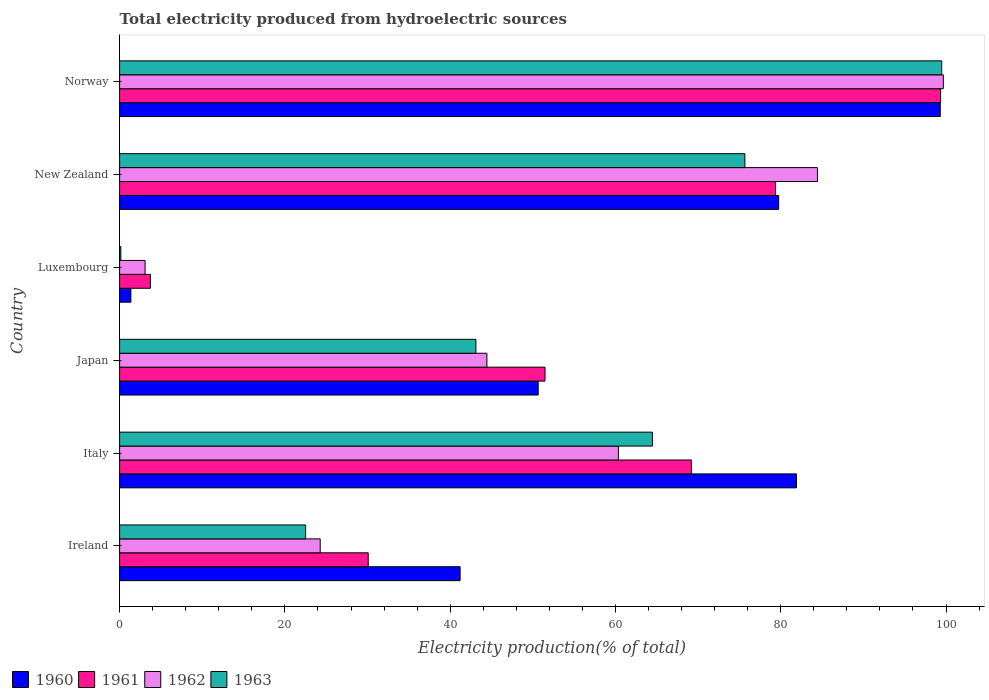Are the number of bars per tick equal to the number of legend labels?
Your answer should be compact. Yes. Are the number of bars on each tick of the Y-axis equal?
Give a very brief answer. Yes. How many bars are there on the 2nd tick from the top?
Your answer should be very brief. 4. How many bars are there on the 6th tick from the bottom?
Keep it short and to the point. 4. What is the label of the 2nd group of bars from the top?
Provide a short and direct response. New Zealand. In how many cases, is the number of bars for a given country not equal to the number of legend labels?
Make the answer very short. 0. What is the total electricity produced in 1961 in Ireland?
Offer a terse response. 30.09. Across all countries, what is the maximum total electricity produced in 1962?
Your answer should be compact. 99.67. Across all countries, what is the minimum total electricity produced in 1962?
Offer a terse response. 3.08. In which country was the total electricity produced in 1960 maximum?
Offer a very short reply. Norway. In which country was the total electricity produced in 1963 minimum?
Provide a short and direct response. Luxembourg. What is the total total electricity produced in 1961 in the graph?
Your response must be concise. 333.2. What is the difference between the total electricity produced in 1962 in Ireland and that in Japan?
Make the answer very short. -20.17. What is the difference between the total electricity produced in 1961 in Italy and the total electricity produced in 1962 in Luxembourg?
Your answer should be very brief. 66.11. What is the average total electricity produced in 1962 per country?
Make the answer very short. 52.71. What is the difference between the total electricity produced in 1960 and total electricity produced in 1961 in Ireland?
Offer a very short reply. 11.12. What is the ratio of the total electricity produced in 1962 in Italy to that in Norway?
Provide a succinct answer. 0.61. Is the total electricity produced in 1962 in Japan less than that in New Zealand?
Provide a succinct answer. Yes. Is the difference between the total electricity produced in 1960 in Ireland and Norway greater than the difference between the total electricity produced in 1961 in Ireland and Norway?
Ensure brevity in your answer.  Yes. What is the difference between the highest and the second highest total electricity produced in 1962?
Provide a short and direct response. 15.23. What is the difference between the highest and the lowest total electricity produced in 1963?
Provide a succinct answer. 99.33. In how many countries, is the total electricity produced in 1963 greater than the average total electricity produced in 1963 taken over all countries?
Your answer should be very brief. 3. Is the sum of the total electricity produced in 1963 in Ireland and Japan greater than the maximum total electricity produced in 1962 across all countries?
Give a very brief answer. No. What does the 4th bar from the bottom in Italy represents?
Provide a short and direct response. 1963. Is it the case that in every country, the sum of the total electricity produced in 1962 and total electricity produced in 1960 is greater than the total electricity produced in 1963?
Offer a very short reply. Yes. Are all the bars in the graph horizontal?
Keep it short and to the point. Yes. What is the difference between two consecutive major ticks on the X-axis?
Your answer should be compact. 20. Does the graph contain any zero values?
Give a very brief answer. No. Does the graph contain grids?
Your response must be concise. No. How are the legend labels stacked?
Offer a terse response. Horizontal. What is the title of the graph?
Your response must be concise. Total electricity produced from hydroelectric sources. Does "1991" appear as one of the legend labels in the graph?
Keep it short and to the point. No. What is the label or title of the X-axis?
Provide a short and direct response. Electricity production(% of total). What is the Electricity production(% of total) in 1960 in Ireland?
Provide a succinct answer. 41.2. What is the Electricity production(% of total) of 1961 in Ireland?
Offer a terse response. 30.09. What is the Electricity production(% of total) of 1962 in Ireland?
Give a very brief answer. 24.27. What is the Electricity production(% of total) of 1963 in Ireland?
Offer a very short reply. 22.51. What is the Electricity production(% of total) of 1960 in Italy?
Ensure brevity in your answer.  81.9. What is the Electricity production(% of total) in 1961 in Italy?
Offer a terse response. 69.19. What is the Electricity production(% of total) in 1962 in Italy?
Your answer should be very brief. 60.35. What is the Electricity production(% of total) of 1963 in Italy?
Provide a succinct answer. 64.47. What is the Electricity production(% of total) in 1960 in Japan?
Keep it short and to the point. 50.65. What is the Electricity production(% of total) of 1961 in Japan?
Keep it short and to the point. 51.48. What is the Electricity production(% of total) of 1962 in Japan?
Offer a terse response. 44.44. What is the Electricity production(% of total) in 1963 in Japan?
Provide a short and direct response. 43.11. What is the Electricity production(% of total) of 1960 in Luxembourg?
Provide a short and direct response. 1.37. What is the Electricity production(% of total) of 1961 in Luxembourg?
Ensure brevity in your answer.  3.73. What is the Electricity production(% of total) of 1962 in Luxembourg?
Offer a very short reply. 3.08. What is the Electricity production(% of total) in 1963 in Luxembourg?
Make the answer very short. 0.15. What is the Electricity production(% of total) in 1960 in New Zealand?
Your answer should be compact. 79.75. What is the Electricity production(% of total) in 1961 in New Zealand?
Your answer should be compact. 79.37. What is the Electricity production(% of total) of 1962 in New Zealand?
Offer a very short reply. 84.44. What is the Electricity production(% of total) of 1963 in New Zealand?
Keep it short and to the point. 75.66. What is the Electricity production(% of total) of 1960 in Norway?
Offer a very short reply. 99.3. What is the Electricity production(% of total) of 1961 in Norway?
Your answer should be very brief. 99.34. What is the Electricity production(% of total) in 1962 in Norway?
Your answer should be very brief. 99.67. What is the Electricity production(% of total) in 1963 in Norway?
Make the answer very short. 99.47. Across all countries, what is the maximum Electricity production(% of total) in 1960?
Your answer should be very brief. 99.3. Across all countries, what is the maximum Electricity production(% of total) in 1961?
Your answer should be compact. 99.34. Across all countries, what is the maximum Electricity production(% of total) in 1962?
Ensure brevity in your answer.  99.67. Across all countries, what is the maximum Electricity production(% of total) in 1963?
Ensure brevity in your answer.  99.47. Across all countries, what is the minimum Electricity production(% of total) of 1960?
Offer a terse response. 1.37. Across all countries, what is the minimum Electricity production(% of total) in 1961?
Your answer should be compact. 3.73. Across all countries, what is the minimum Electricity production(% of total) in 1962?
Ensure brevity in your answer.  3.08. Across all countries, what is the minimum Electricity production(% of total) in 1963?
Keep it short and to the point. 0.15. What is the total Electricity production(% of total) in 1960 in the graph?
Provide a short and direct response. 354.17. What is the total Electricity production(% of total) of 1961 in the graph?
Keep it short and to the point. 333.2. What is the total Electricity production(% of total) in 1962 in the graph?
Your response must be concise. 316.26. What is the total Electricity production(% of total) of 1963 in the graph?
Keep it short and to the point. 305.37. What is the difference between the Electricity production(% of total) in 1960 in Ireland and that in Italy?
Offer a terse response. -40.7. What is the difference between the Electricity production(% of total) of 1961 in Ireland and that in Italy?
Offer a terse response. -39.1. What is the difference between the Electricity production(% of total) in 1962 in Ireland and that in Italy?
Make the answer very short. -36.08. What is the difference between the Electricity production(% of total) of 1963 in Ireland and that in Italy?
Give a very brief answer. -41.96. What is the difference between the Electricity production(% of total) in 1960 in Ireland and that in Japan?
Give a very brief answer. -9.45. What is the difference between the Electricity production(% of total) in 1961 in Ireland and that in Japan?
Your answer should be compact. -21.39. What is the difference between the Electricity production(% of total) in 1962 in Ireland and that in Japan?
Make the answer very short. -20.17. What is the difference between the Electricity production(% of total) of 1963 in Ireland and that in Japan?
Offer a very short reply. -20.61. What is the difference between the Electricity production(% of total) of 1960 in Ireland and that in Luxembourg?
Offer a terse response. 39.84. What is the difference between the Electricity production(% of total) in 1961 in Ireland and that in Luxembourg?
Your answer should be compact. 26.36. What is the difference between the Electricity production(% of total) of 1962 in Ireland and that in Luxembourg?
Ensure brevity in your answer.  21.19. What is the difference between the Electricity production(% of total) of 1963 in Ireland and that in Luxembourg?
Provide a short and direct response. 22.36. What is the difference between the Electricity production(% of total) of 1960 in Ireland and that in New Zealand?
Provide a short and direct response. -38.55. What is the difference between the Electricity production(% of total) in 1961 in Ireland and that in New Zealand?
Keep it short and to the point. -49.29. What is the difference between the Electricity production(% of total) of 1962 in Ireland and that in New Zealand?
Give a very brief answer. -60.17. What is the difference between the Electricity production(% of total) in 1963 in Ireland and that in New Zealand?
Keep it short and to the point. -53.15. What is the difference between the Electricity production(% of total) of 1960 in Ireland and that in Norway?
Provide a succinct answer. -58.1. What is the difference between the Electricity production(% of total) of 1961 in Ireland and that in Norway?
Give a very brief answer. -69.26. What is the difference between the Electricity production(% of total) in 1962 in Ireland and that in Norway?
Your answer should be compact. -75.4. What is the difference between the Electricity production(% of total) of 1963 in Ireland and that in Norway?
Offer a very short reply. -76.97. What is the difference between the Electricity production(% of total) in 1960 in Italy and that in Japan?
Provide a succinct answer. 31.25. What is the difference between the Electricity production(% of total) of 1961 in Italy and that in Japan?
Give a very brief answer. 17.71. What is the difference between the Electricity production(% of total) in 1962 in Italy and that in Japan?
Your answer should be very brief. 15.91. What is the difference between the Electricity production(% of total) in 1963 in Italy and that in Japan?
Provide a succinct answer. 21.35. What is the difference between the Electricity production(% of total) in 1960 in Italy and that in Luxembourg?
Give a very brief answer. 80.53. What is the difference between the Electricity production(% of total) in 1961 in Italy and that in Luxembourg?
Ensure brevity in your answer.  65.46. What is the difference between the Electricity production(% of total) in 1962 in Italy and that in Luxembourg?
Your answer should be very brief. 57.27. What is the difference between the Electricity production(% of total) of 1963 in Italy and that in Luxembourg?
Provide a short and direct response. 64.32. What is the difference between the Electricity production(% of total) of 1960 in Italy and that in New Zealand?
Provide a succinct answer. 2.15. What is the difference between the Electricity production(% of total) of 1961 in Italy and that in New Zealand?
Your response must be concise. -10.18. What is the difference between the Electricity production(% of total) of 1962 in Italy and that in New Zealand?
Offer a terse response. -24.08. What is the difference between the Electricity production(% of total) of 1963 in Italy and that in New Zealand?
Offer a terse response. -11.19. What is the difference between the Electricity production(% of total) of 1960 in Italy and that in Norway?
Offer a terse response. -17.4. What is the difference between the Electricity production(% of total) in 1961 in Italy and that in Norway?
Offer a terse response. -30.15. What is the difference between the Electricity production(% of total) of 1962 in Italy and that in Norway?
Give a very brief answer. -39.32. What is the difference between the Electricity production(% of total) of 1963 in Italy and that in Norway?
Keep it short and to the point. -35.01. What is the difference between the Electricity production(% of total) in 1960 in Japan and that in Luxembourg?
Your answer should be very brief. 49.28. What is the difference between the Electricity production(% of total) of 1961 in Japan and that in Luxembourg?
Your answer should be very brief. 47.75. What is the difference between the Electricity production(% of total) of 1962 in Japan and that in Luxembourg?
Offer a very short reply. 41.36. What is the difference between the Electricity production(% of total) of 1963 in Japan and that in Luxembourg?
Provide a short and direct response. 42.97. What is the difference between the Electricity production(% of total) in 1960 in Japan and that in New Zealand?
Make the answer very short. -29.1. What is the difference between the Electricity production(% of total) of 1961 in Japan and that in New Zealand?
Provide a succinct answer. -27.9. What is the difference between the Electricity production(% of total) of 1962 in Japan and that in New Zealand?
Your answer should be very brief. -39.99. What is the difference between the Electricity production(% of total) of 1963 in Japan and that in New Zealand?
Give a very brief answer. -32.54. What is the difference between the Electricity production(% of total) in 1960 in Japan and that in Norway?
Your answer should be compact. -48.65. What is the difference between the Electricity production(% of total) in 1961 in Japan and that in Norway?
Your response must be concise. -47.87. What is the difference between the Electricity production(% of total) of 1962 in Japan and that in Norway?
Give a very brief answer. -55.23. What is the difference between the Electricity production(% of total) in 1963 in Japan and that in Norway?
Provide a succinct answer. -56.36. What is the difference between the Electricity production(% of total) of 1960 in Luxembourg and that in New Zealand?
Offer a very short reply. -78.38. What is the difference between the Electricity production(% of total) in 1961 in Luxembourg and that in New Zealand?
Provide a succinct answer. -75.64. What is the difference between the Electricity production(% of total) in 1962 in Luxembourg and that in New Zealand?
Your response must be concise. -81.36. What is the difference between the Electricity production(% of total) of 1963 in Luxembourg and that in New Zealand?
Offer a very short reply. -75.51. What is the difference between the Electricity production(% of total) of 1960 in Luxembourg and that in Norway?
Keep it short and to the point. -97.93. What is the difference between the Electricity production(% of total) in 1961 in Luxembourg and that in Norway?
Ensure brevity in your answer.  -95.61. What is the difference between the Electricity production(% of total) in 1962 in Luxembourg and that in Norway?
Give a very brief answer. -96.59. What is the difference between the Electricity production(% of total) of 1963 in Luxembourg and that in Norway?
Your answer should be very brief. -99.33. What is the difference between the Electricity production(% of total) of 1960 in New Zealand and that in Norway?
Keep it short and to the point. -19.55. What is the difference between the Electricity production(% of total) in 1961 in New Zealand and that in Norway?
Keep it short and to the point. -19.97. What is the difference between the Electricity production(% of total) in 1962 in New Zealand and that in Norway?
Your answer should be compact. -15.23. What is the difference between the Electricity production(% of total) in 1963 in New Zealand and that in Norway?
Your answer should be compact. -23.82. What is the difference between the Electricity production(% of total) of 1960 in Ireland and the Electricity production(% of total) of 1961 in Italy?
Make the answer very short. -27.99. What is the difference between the Electricity production(% of total) in 1960 in Ireland and the Electricity production(% of total) in 1962 in Italy?
Your response must be concise. -19.15. What is the difference between the Electricity production(% of total) of 1960 in Ireland and the Electricity production(% of total) of 1963 in Italy?
Keep it short and to the point. -23.27. What is the difference between the Electricity production(% of total) of 1961 in Ireland and the Electricity production(% of total) of 1962 in Italy?
Ensure brevity in your answer.  -30.27. What is the difference between the Electricity production(% of total) in 1961 in Ireland and the Electricity production(% of total) in 1963 in Italy?
Give a very brief answer. -34.38. What is the difference between the Electricity production(% of total) of 1962 in Ireland and the Electricity production(% of total) of 1963 in Italy?
Provide a short and direct response. -40.2. What is the difference between the Electricity production(% of total) in 1960 in Ireland and the Electricity production(% of total) in 1961 in Japan?
Keep it short and to the point. -10.27. What is the difference between the Electricity production(% of total) in 1960 in Ireland and the Electricity production(% of total) in 1962 in Japan?
Offer a very short reply. -3.24. What is the difference between the Electricity production(% of total) of 1960 in Ireland and the Electricity production(% of total) of 1963 in Japan?
Provide a short and direct response. -1.91. What is the difference between the Electricity production(% of total) in 1961 in Ireland and the Electricity production(% of total) in 1962 in Japan?
Your answer should be compact. -14.36. What is the difference between the Electricity production(% of total) of 1961 in Ireland and the Electricity production(% of total) of 1963 in Japan?
Keep it short and to the point. -13.03. What is the difference between the Electricity production(% of total) in 1962 in Ireland and the Electricity production(% of total) in 1963 in Japan?
Provide a short and direct response. -18.84. What is the difference between the Electricity production(% of total) in 1960 in Ireland and the Electricity production(% of total) in 1961 in Luxembourg?
Keep it short and to the point. 37.47. What is the difference between the Electricity production(% of total) of 1960 in Ireland and the Electricity production(% of total) of 1962 in Luxembourg?
Your answer should be compact. 38.12. What is the difference between the Electricity production(% of total) in 1960 in Ireland and the Electricity production(% of total) in 1963 in Luxembourg?
Your answer should be compact. 41.05. What is the difference between the Electricity production(% of total) of 1961 in Ireland and the Electricity production(% of total) of 1962 in Luxembourg?
Offer a very short reply. 27. What is the difference between the Electricity production(% of total) in 1961 in Ireland and the Electricity production(% of total) in 1963 in Luxembourg?
Make the answer very short. 29.94. What is the difference between the Electricity production(% of total) in 1962 in Ireland and the Electricity production(% of total) in 1963 in Luxembourg?
Offer a very short reply. 24.12. What is the difference between the Electricity production(% of total) in 1960 in Ireland and the Electricity production(% of total) in 1961 in New Zealand?
Provide a short and direct response. -38.17. What is the difference between the Electricity production(% of total) of 1960 in Ireland and the Electricity production(% of total) of 1962 in New Zealand?
Keep it short and to the point. -43.24. What is the difference between the Electricity production(% of total) in 1960 in Ireland and the Electricity production(% of total) in 1963 in New Zealand?
Give a very brief answer. -34.46. What is the difference between the Electricity production(% of total) of 1961 in Ireland and the Electricity production(% of total) of 1962 in New Zealand?
Provide a short and direct response. -54.35. What is the difference between the Electricity production(% of total) in 1961 in Ireland and the Electricity production(% of total) in 1963 in New Zealand?
Offer a very short reply. -45.57. What is the difference between the Electricity production(% of total) in 1962 in Ireland and the Electricity production(% of total) in 1963 in New Zealand?
Ensure brevity in your answer.  -51.39. What is the difference between the Electricity production(% of total) in 1960 in Ireland and the Electricity production(% of total) in 1961 in Norway?
Your answer should be very brief. -58.14. What is the difference between the Electricity production(% of total) of 1960 in Ireland and the Electricity production(% of total) of 1962 in Norway?
Your answer should be very brief. -58.47. What is the difference between the Electricity production(% of total) of 1960 in Ireland and the Electricity production(% of total) of 1963 in Norway?
Provide a short and direct response. -58.27. What is the difference between the Electricity production(% of total) of 1961 in Ireland and the Electricity production(% of total) of 1962 in Norway?
Offer a terse response. -69.58. What is the difference between the Electricity production(% of total) in 1961 in Ireland and the Electricity production(% of total) in 1963 in Norway?
Keep it short and to the point. -69.39. What is the difference between the Electricity production(% of total) in 1962 in Ireland and the Electricity production(% of total) in 1963 in Norway?
Provide a short and direct response. -75.2. What is the difference between the Electricity production(% of total) of 1960 in Italy and the Electricity production(% of total) of 1961 in Japan?
Provide a short and direct response. 30.42. What is the difference between the Electricity production(% of total) in 1960 in Italy and the Electricity production(% of total) in 1962 in Japan?
Your answer should be compact. 37.46. What is the difference between the Electricity production(% of total) in 1960 in Italy and the Electricity production(% of total) in 1963 in Japan?
Make the answer very short. 38.79. What is the difference between the Electricity production(% of total) in 1961 in Italy and the Electricity production(% of total) in 1962 in Japan?
Your response must be concise. 24.75. What is the difference between the Electricity production(% of total) in 1961 in Italy and the Electricity production(% of total) in 1963 in Japan?
Give a very brief answer. 26.08. What is the difference between the Electricity production(% of total) in 1962 in Italy and the Electricity production(% of total) in 1963 in Japan?
Offer a very short reply. 17.24. What is the difference between the Electricity production(% of total) in 1960 in Italy and the Electricity production(% of total) in 1961 in Luxembourg?
Provide a short and direct response. 78.17. What is the difference between the Electricity production(% of total) in 1960 in Italy and the Electricity production(% of total) in 1962 in Luxembourg?
Make the answer very short. 78.82. What is the difference between the Electricity production(% of total) of 1960 in Italy and the Electricity production(% of total) of 1963 in Luxembourg?
Your response must be concise. 81.75. What is the difference between the Electricity production(% of total) in 1961 in Italy and the Electricity production(% of total) in 1962 in Luxembourg?
Ensure brevity in your answer.  66.11. What is the difference between the Electricity production(% of total) in 1961 in Italy and the Electricity production(% of total) in 1963 in Luxembourg?
Your response must be concise. 69.04. What is the difference between the Electricity production(% of total) in 1962 in Italy and the Electricity production(% of total) in 1963 in Luxembourg?
Give a very brief answer. 60.21. What is the difference between the Electricity production(% of total) of 1960 in Italy and the Electricity production(% of total) of 1961 in New Zealand?
Keep it short and to the point. 2.53. What is the difference between the Electricity production(% of total) in 1960 in Italy and the Electricity production(% of total) in 1962 in New Zealand?
Offer a terse response. -2.54. What is the difference between the Electricity production(% of total) of 1960 in Italy and the Electricity production(% of total) of 1963 in New Zealand?
Provide a succinct answer. 6.24. What is the difference between the Electricity production(% of total) of 1961 in Italy and the Electricity production(% of total) of 1962 in New Zealand?
Provide a succinct answer. -15.25. What is the difference between the Electricity production(% of total) in 1961 in Italy and the Electricity production(% of total) in 1963 in New Zealand?
Keep it short and to the point. -6.47. What is the difference between the Electricity production(% of total) in 1962 in Italy and the Electricity production(% of total) in 1963 in New Zealand?
Your answer should be very brief. -15.3. What is the difference between the Electricity production(% of total) of 1960 in Italy and the Electricity production(% of total) of 1961 in Norway?
Ensure brevity in your answer.  -17.44. What is the difference between the Electricity production(% of total) of 1960 in Italy and the Electricity production(% of total) of 1962 in Norway?
Give a very brief answer. -17.77. What is the difference between the Electricity production(% of total) of 1960 in Italy and the Electricity production(% of total) of 1963 in Norway?
Your answer should be compact. -17.57. What is the difference between the Electricity production(% of total) of 1961 in Italy and the Electricity production(% of total) of 1962 in Norway?
Offer a terse response. -30.48. What is the difference between the Electricity production(% of total) of 1961 in Italy and the Electricity production(% of total) of 1963 in Norway?
Provide a succinct answer. -30.28. What is the difference between the Electricity production(% of total) of 1962 in Italy and the Electricity production(% of total) of 1963 in Norway?
Keep it short and to the point. -39.12. What is the difference between the Electricity production(% of total) of 1960 in Japan and the Electricity production(% of total) of 1961 in Luxembourg?
Provide a short and direct response. 46.92. What is the difference between the Electricity production(% of total) of 1960 in Japan and the Electricity production(% of total) of 1962 in Luxembourg?
Your answer should be compact. 47.57. What is the difference between the Electricity production(% of total) of 1960 in Japan and the Electricity production(% of total) of 1963 in Luxembourg?
Your response must be concise. 50.5. What is the difference between the Electricity production(% of total) of 1961 in Japan and the Electricity production(% of total) of 1962 in Luxembourg?
Ensure brevity in your answer.  48.39. What is the difference between the Electricity production(% of total) in 1961 in Japan and the Electricity production(% of total) in 1963 in Luxembourg?
Your answer should be very brief. 51.33. What is the difference between the Electricity production(% of total) in 1962 in Japan and the Electricity production(% of total) in 1963 in Luxembourg?
Give a very brief answer. 44.3. What is the difference between the Electricity production(% of total) of 1960 in Japan and the Electricity production(% of total) of 1961 in New Zealand?
Offer a very short reply. -28.72. What is the difference between the Electricity production(% of total) in 1960 in Japan and the Electricity production(% of total) in 1962 in New Zealand?
Keep it short and to the point. -33.79. What is the difference between the Electricity production(% of total) in 1960 in Japan and the Electricity production(% of total) in 1963 in New Zealand?
Provide a succinct answer. -25.01. What is the difference between the Electricity production(% of total) of 1961 in Japan and the Electricity production(% of total) of 1962 in New Zealand?
Offer a very short reply. -32.96. What is the difference between the Electricity production(% of total) of 1961 in Japan and the Electricity production(% of total) of 1963 in New Zealand?
Your response must be concise. -24.18. What is the difference between the Electricity production(% of total) in 1962 in Japan and the Electricity production(% of total) in 1963 in New Zealand?
Offer a very short reply. -31.21. What is the difference between the Electricity production(% of total) of 1960 in Japan and the Electricity production(% of total) of 1961 in Norway?
Keep it short and to the point. -48.69. What is the difference between the Electricity production(% of total) in 1960 in Japan and the Electricity production(% of total) in 1962 in Norway?
Your response must be concise. -49.02. What is the difference between the Electricity production(% of total) in 1960 in Japan and the Electricity production(% of total) in 1963 in Norway?
Your answer should be very brief. -48.83. What is the difference between the Electricity production(% of total) of 1961 in Japan and the Electricity production(% of total) of 1962 in Norway?
Offer a terse response. -48.19. What is the difference between the Electricity production(% of total) in 1961 in Japan and the Electricity production(% of total) in 1963 in Norway?
Your answer should be compact. -48. What is the difference between the Electricity production(% of total) of 1962 in Japan and the Electricity production(% of total) of 1963 in Norway?
Make the answer very short. -55.03. What is the difference between the Electricity production(% of total) of 1960 in Luxembourg and the Electricity production(% of total) of 1961 in New Zealand?
Ensure brevity in your answer.  -78.01. What is the difference between the Electricity production(% of total) in 1960 in Luxembourg and the Electricity production(% of total) in 1962 in New Zealand?
Your answer should be compact. -83.07. What is the difference between the Electricity production(% of total) of 1960 in Luxembourg and the Electricity production(% of total) of 1963 in New Zealand?
Keep it short and to the point. -74.29. What is the difference between the Electricity production(% of total) of 1961 in Luxembourg and the Electricity production(% of total) of 1962 in New Zealand?
Your answer should be compact. -80.71. What is the difference between the Electricity production(% of total) of 1961 in Luxembourg and the Electricity production(% of total) of 1963 in New Zealand?
Offer a very short reply. -71.93. What is the difference between the Electricity production(% of total) in 1962 in Luxembourg and the Electricity production(% of total) in 1963 in New Zealand?
Give a very brief answer. -72.58. What is the difference between the Electricity production(% of total) in 1960 in Luxembourg and the Electricity production(% of total) in 1961 in Norway?
Your answer should be compact. -97.98. What is the difference between the Electricity production(% of total) of 1960 in Luxembourg and the Electricity production(% of total) of 1962 in Norway?
Your response must be concise. -98.3. What is the difference between the Electricity production(% of total) in 1960 in Luxembourg and the Electricity production(% of total) in 1963 in Norway?
Keep it short and to the point. -98.11. What is the difference between the Electricity production(% of total) of 1961 in Luxembourg and the Electricity production(% of total) of 1962 in Norway?
Provide a succinct answer. -95.94. What is the difference between the Electricity production(% of total) of 1961 in Luxembourg and the Electricity production(% of total) of 1963 in Norway?
Offer a very short reply. -95.74. What is the difference between the Electricity production(% of total) in 1962 in Luxembourg and the Electricity production(% of total) in 1963 in Norway?
Your response must be concise. -96.39. What is the difference between the Electricity production(% of total) of 1960 in New Zealand and the Electricity production(% of total) of 1961 in Norway?
Your answer should be very brief. -19.59. What is the difference between the Electricity production(% of total) in 1960 in New Zealand and the Electricity production(% of total) in 1962 in Norway?
Your answer should be very brief. -19.92. What is the difference between the Electricity production(% of total) of 1960 in New Zealand and the Electricity production(% of total) of 1963 in Norway?
Ensure brevity in your answer.  -19.72. What is the difference between the Electricity production(% of total) in 1961 in New Zealand and the Electricity production(% of total) in 1962 in Norway?
Offer a terse response. -20.3. What is the difference between the Electricity production(% of total) in 1961 in New Zealand and the Electricity production(% of total) in 1963 in Norway?
Ensure brevity in your answer.  -20.1. What is the difference between the Electricity production(% of total) in 1962 in New Zealand and the Electricity production(% of total) in 1963 in Norway?
Your answer should be compact. -15.04. What is the average Electricity production(% of total) in 1960 per country?
Make the answer very short. 59.03. What is the average Electricity production(% of total) of 1961 per country?
Ensure brevity in your answer.  55.53. What is the average Electricity production(% of total) of 1962 per country?
Give a very brief answer. 52.71. What is the average Electricity production(% of total) in 1963 per country?
Give a very brief answer. 50.9. What is the difference between the Electricity production(% of total) in 1960 and Electricity production(% of total) in 1961 in Ireland?
Your response must be concise. 11.12. What is the difference between the Electricity production(% of total) in 1960 and Electricity production(% of total) in 1962 in Ireland?
Offer a terse response. 16.93. What is the difference between the Electricity production(% of total) of 1960 and Electricity production(% of total) of 1963 in Ireland?
Provide a short and direct response. 18.69. What is the difference between the Electricity production(% of total) in 1961 and Electricity production(% of total) in 1962 in Ireland?
Provide a short and direct response. 5.81. What is the difference between the Electricity production(% of total) of 1961 and Electricity production(% of total) of 1963 in Ireland?
Offer a very short reply. 7.58. What is the difference between the Electricity production(% of total) of 1962 and Electricity production(% of total) of 1963 in Ireland?
Offer a very short reply. 1.76. What is the difference between the Electricity production(% of total) of 1960 and Electricity production(% of total) of 1961 in Italy?
Provide a succinct answer. 12.71. What is the difference between the Electricity production(% of total) in 1960 and Electricity production(% of total) in 1962 in Italy?
Offer a very short reply. 21.55. What is the difference between the Electricity production(% of total) of 1960 and Electricity production(% of total) of 1963 in Italy?
Your response must be concise. 17.43. What is the difference between the Electricity production(% of total) in 1961 and Electricity production(% of total) in 1962 in Italy?
Ensure brevity in your answer.  8.84. What is the difference between the Electricity production(% of total) of 1961 and Electricity production(% of total) of 1963 in Italy?
Make the answer very short. 4.72. What is the difference between the Electricity production(% of total) of 1962 and Electricity production(% of total) of 1963 in Italy?
Give a very brief answer. -4.11. What is the difference between the Electricity production(% of total) in 1960 and Electricity production(% of total) in 1961 in Japan?
Your answer should be very brief. -0.83. What is the difference between the Electricity production(% of total) of 1960 and Electricity production(% of total) of 1962 in Japan?
Your response must be concise. 6.2. What is the difference between the Electricity production(% of total) of 1960 and Electricity production(% of total) of 1963 in Japan?
Offer a very short reply. 7.54. What is the difference between the Electricity production(% of total) of 1961 and Electricity production(% of total) of 1962 in Japan?
Give a very brief answer. 7.03. What is the difference between the Electricity production(% of total) in 1961 and Electricity production(% of total) in 1963 in Japan?
Make the answer very short. 8.36. What is the difference between the Electricity production(% of total) of 1962 and Electricity production(% of total) of 1963 in Japan?
Keep it short and to the point. 1.33. What is the difference between the Electricity production(% of total) in 1960 and Electricity production(% of total) in 1961 in Luxembourg?
Provide a short and direct response. -2.36. What is the difference between the Electricity production(% of total) in 1960 and Electricity production(% of total) in 1962 in Luxembourg?
Offer a terse response. -1.72. What is the difference between the Electricity production(% of total) of 1960 and Electricity production(% of total) of 1963 in Luxembourg?
Your answer should be very brief. 1.22. What is the difference between the Electricity production(% of total) in 1961 and Electricity production(% of total) in 1962 in Luxembourg?
Your answer should be very brief. 0.65. What is the difference between the Electricity production(% of total) of 1961 and Electricity production(% of total) of 1963 in Luxembourg?
Ensure brevity in your answer.  3.58. What is the difference between the Electricity production(% of total) of 1962 and Electricity production(% of total) of 1963 in Luxembourg?
Provide a short and direct response. 2.93. What is the difference between the Electricity production(% of total) of 1960 and Electricity production(% of total) of 1961 in New Zealand?
Offer a very short reply. 0.38. What is the difference between the Electricity production(% of total) in 1960 and Electricity production(% of total) in 1962 in New Zealand?
Offer a very short reply. -4.69. What is the difference between the Electricity production(% of total) of 1960 and Electricity production(% of total) of 1963 in New Zealand?
Offer a very short reply. 4.09. What is the difference between the Electricity production(% of total) in 1961 and Electricity production(% of total) in 1962 in New Zealand?
Your answer should be very brief. -5.07. What is the difference between the Electricity production(% of total) in 1961 and Electricity production(% of total) in 1963 in New Zealand?
Keep it short and to the point. 3.71. What is the difference between the Electricity production(% of total) in 1962 and Electricity production(% of total) in 1963 in New Zealand?
Offer a terse response. 8.78. What is the difference between the Electricity production(% of total) in 1960 and Electricity production(% of total) in 1961 in Norway?
Ensure brevity in your answer.  -0.04. What is the difference between the Electricity production(% of total) in 1960 and Electricity production(% of total) in 1962 in Norway?
Your response must be concise. -0.37. What is the difference between the Electricity production(% of total) of 1960 and Electricity production(% of total) of 1963 in Norway?
Give a very brief answer. -0.17. What is the difference between the Electricity production(% of total) of 1961 and Electricity production(% of total) of 1962 in Norway?
Keep it short and to the point. -0.33. What is the difference between the Electricity production(% of total) of 1961 and Electricity production(% of total) of 1963 in Norway?
Keep it short and to the point. -0.13. What is the difference between the Electricity production(% of total) of 1962 and Electricity production(% of total) of 1963 in Norway?
Offer a very short reply. 0.19. What is the ratio of the Electricity production(% of total) in 1960 in Ireland to that in Italy?
Provide a short and direct response. 0.5. What is the ratio of the Electricity production(% of total) of 1961 in Ireland to that in Italy?
Your answer should be compact. 0.43. What is the ratio of the Electricity production(% of total) in 1962 in Ireland to that in Italy?
Provide a short and direct response. 0.4. What is the ratio of the Electricity production(% of total) in 1963 in Ireland to that in Italy?
Ensure brevity in your answer.  0.35. What is the ratio of the Electricity production(% of total) in 1960 in Ireland to that in Japan?
Offer a terse response. 0.81. What is the ratio of the Electricity production(% of total) in 1961 in Ireland to that in Japan?
Provide a succinct answer. 0.58. What is the ratio of the Electricity production(% of total) in 1962 in Ireland to that in Japan?
Offer a very short reply. 0.55. What is the ratio of the Electricity production(% of total) of 1963 in Ireland to that in Japan?
Offer a terse response. 0.52. What is the ratio of the Electricity production(% of total) of 1960 in Ireland to that in Luxembourg?
Give a very brief answer. 30.16. What is the ratio of the Electricity production(% of total) of 1961 in Ireland to that in Luxembourg?
Offer a very short reply. 8.07. What is the ratio of the Electricity production(% of total) of 1962 in Ireland to that in Luxembourg?
Offer a very short reply. 7.88. What is the ratio of the Electricity production(% of total) of 1963 in Ireland to that in Luxembourg?
Provide a short and direct response. 152.5. What is the ratio of the Electricity production(% of total) of 1960 in Ireland to that in New Zealand?
Ensure brevity in your answer.  0.52. What is the ratio of the Electricity production(% of total) of 1961 in Ireland to that in New Zealand?
Your answer should be very brief. 0.38. What is the ratio of the Electricity production(% of total) of 1962 in Ireland to that in New Zealand?
Give a very brief answer. 0.29. What is the ratio of the Electricity production(% of total) of 1963 in Ireland to that in New Zealand?
Offer a terse response. 0.3. What is the ratio of the Electricity production(% of total) in 1960 in Ireland to that in Norway?
Keep it short and to the point. 0.41. What is the ratio of the Electricity production(% of total) in 1961 in Ireland to that in Norway?
Your response must be concise. 0.3. What is the ratio of the Electricity production(% of total) in 1962 in Ireland to that in Norway?
Make the answer very short. 0.24. What is the ratio of the Electricity production(% of total) in 1963 in Ireland to that in Norway?
Your answer should be compact. 0.23. What is the ratio of the Electricity production(% of total) of 1960 in Italy to that in Japan?
Offer a terse response. 1.62. What is the ratio of the Electricity production(% of total) in 1961 in Italy to that in Japan?
Give a very brief answer. 1.34. What is the ratio of the Electricity production(% of total) in 1962 in Italy to that in Japan?
Your answer should be very brief. 1.36. What is the ratio of the Electricity production(% of total) of 1963 in Italy to that in Japan?
Make the answer very short. 1.5. What is the ratio of the Electricity production(% of total) of 1960 in Italy to that in Luxembourg?
Give a very brief answer. 59.95. What is the ratio of the Electricity production(% of total) in 1961 in Italy to that in Luxembourg?
Give a very brief answer. 18.55. What is the ratio of the Electricity production(% of total) of 1962 in Italy to that in Luxembourg?
Your answer should be very brief. 19.58. What is the ratio of the Electricity production(% of total) in 1963 in Italy to that in Luxembourg?
Your answer should be compact. 436.77. What is the ratio of the Electricity production(% of total) of 1961 in Italy to that in New Zealand?
Keep it short and to the point. 0.87. What is the ratio of the Electricity production(% of total) in 1962 in Italy to that in New Zealand?
Give a very brief answer. 0.71. What is the ratio of the Electricity production(% of total) in 1963 in Italy to that in New Zealand?
Ensure brevity in your answer.  0.85. What is the ratio of the Electricity production(% of total) in 1960 in Italy to that in Norway?
Your answer should be compact. 0.82. What is the ratio of the Electricity production(% of total) of 1961 in Italy to that in Norway?
Keep it short and to the point. 0.7. What is the ratio of the Electricity production(% of total) in 1962 in Italy to that in Norway?
Provide a succinct answer. 0.61. What is the ratio of the Electricity production(% of total) in 1963 in Italy to that in Norway?
Your response must be concise. 0.65. What is the ratio of the Electricity production(% of total) of 1960 in Japan to that in Luxembourg?
Make the answer very short. 37.08. What is the ratio of the Electricity production(% of total) in 1961 in Japan to that in Luxembourg?
Your response must be concise. 13.8. What is the ratio of the Electricity production(% of total) in 1962 in Japan to that in Luxembourg?
Your answer should be compact. 14.42. What is the ratio of the Electricity production(% of total) of 1963 in Japan to that in Luxembourg?
Your answer should be compact. 292.1. What is the ratio of the Electricity production(% of total) in 1960 in Japan to that in New Zealand?
Provide a short and direct response. 0.64. What is the ratio of the Electricity production(% of total) in 1961 in Japan to that in New Zealand?
Keep it short and to the point. 0.65. What is the ratio of the Electricity production(% of total) in 1962 in Japan to that in New Zealand?
Make the answer very short. 0.53. What is the ratio of the Electricity production(% of total) of 1963 in Japan to that in New Zealand?
Offer a terse response. 0.57. What is the ratio of the Electricity production(% of total) in 1960 in Japan to that in Norway?
Your answer should be very brief. 0.51. What is the ratio of the Electricity production(% of total) in 1961 in Japan to that in Norway?
Provide a short and direct response. 0.52. What is the ratio of the Electricity production(% of total) of 1962 in Japan to that in Norway?
Provide a short and direct response. 0.45. What is the ratio of the Electricity production(% of total) in 1963 in Japan to that in Norway?
Your answer should be very brief. 0.43. What is the ratio of the Electricity production(% of total) of 1960 in Luxembourg to that in New Zealand?
Provide a short and direct response. 0.02. What is the ratio of the Electricity production(% of total) of 1961 in Luxembourg to that in New Zealand?
Ensure brevity in your answer.  0.05. What is the ratio of the Electricity production(% of total) of 1962 in Luxembourg to that in New Zealand?
Keep it short and to the point. 0.04. What is the ratio of the Electricity production(% of total) of 1963 in Luxembourg to that in New Zealand?
Your answer should be compact. 0. What is the ratio of the Electricity production(% of total) of 1960 in Luxembourg to that in Norway?
Keep it short and to the point. 0.01. What is the ratio of the Electricity production(% of total) of 1961 in Luxembourg to that in Norway?
Provide a short and direct response. 0.04. What is the ratio of the Electricity production(% of total) of 1962 in Luxembourg to that in Norway?
Ensure brevity in your answer.  0.03. What is the ratio of the Electricity production(% of total) in 1963 in Luxembourg to that in Norway?
Give a very brief answer. 0. What is the ratio of the Electricity production(% of total) of 1960 in New Zealand to that in Norway?
Provide a short and direct response. 0.8. What is the ratio of the Electricity production(% of total) of 1961 in New Zealand to that in Norway?
Your response must be concise. 0.8. What is the ratio of the Electricity production(% of total) in 1962 in New Zealand to that in Norway?
Give a very brief answer. 0.85. What is the ratio of the Electricity production(% of total) of 1963 in New Zealand to that in Norway?
Make the answer very short. 0.76. What is the difference between the highest and the second highest Electricity production(% of total) in 1961?
Ensure brevity in your answer.  19.97. What is the difference between the highest and the second highest Electricity production(% of total) of 1962?
Keep it short and to the point. 15.23. What is the difference between the highest and the second highest Electricity production(% of total) of 1963?
Provide a short and direct response. 23.82. What is the difference between the highest and the lowest Electricity production(% of total) in 1960?
Offer a terse response. 97.93. What is the difference between the highest and the lowest Electricity production(% of total) of 1961?
Make the answer very short. 95.61. What is the difference between the highest and the lowest Electricity production(% of total) in 1962?
Offer a terse response. 96.59. What is the difference between the highest and the lowest Electricity production(% of total) of 1963?
Offer a very short reply. 99.33. 